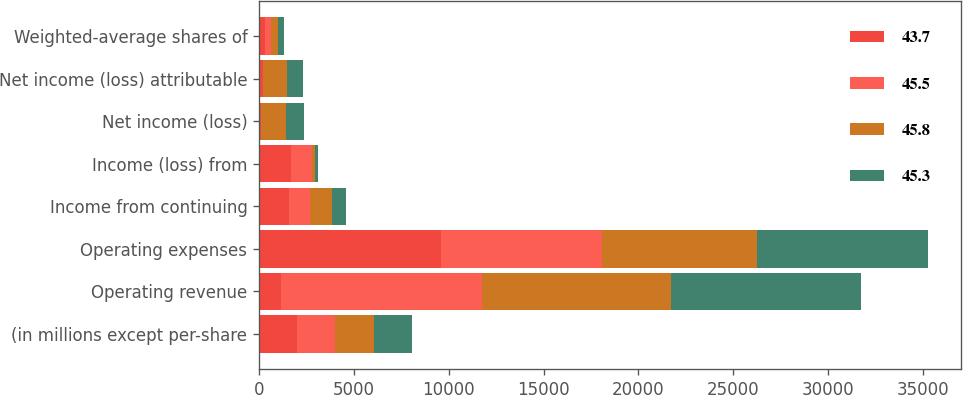Convert chart to OTSL. <chart><loc_0><loc_0><loc_500><loc_500><stacked_bar_chart><ecel><fcel>(in millions except per-share<fcel>Operating revenue<fcel>Operating expenses<fcel>Income from continuing<fcel>Income (loss) from<fcel>Net income (loss)<fcel>Net income (loss) attributable<fcel>Weighted-average shares of<nl><fcel>43.7<fcel>2012<fcel>1144<fcel>9577<fcel>1594<fcel>1686<fcel>92<fcel>183<fcel>326<nl><fcel>45.5<fcel>2011<fcel>10588<fcel>8527<fcel>1100<fcel>1078<fcel>22<fcel>37<fcel>326<nl><fcel>45.8<fcel>2010<fcel>9996<fcel>8177<fcel>1144<fcel>164<fcel>1308<fcel>1256<fcel>326<nl><fcel>45.3<fcel>2009<fcel>9991<fcel>8982<fcel>751<fcel>197<fcel>948<fcel>849<fcel>326<nl></chart> 